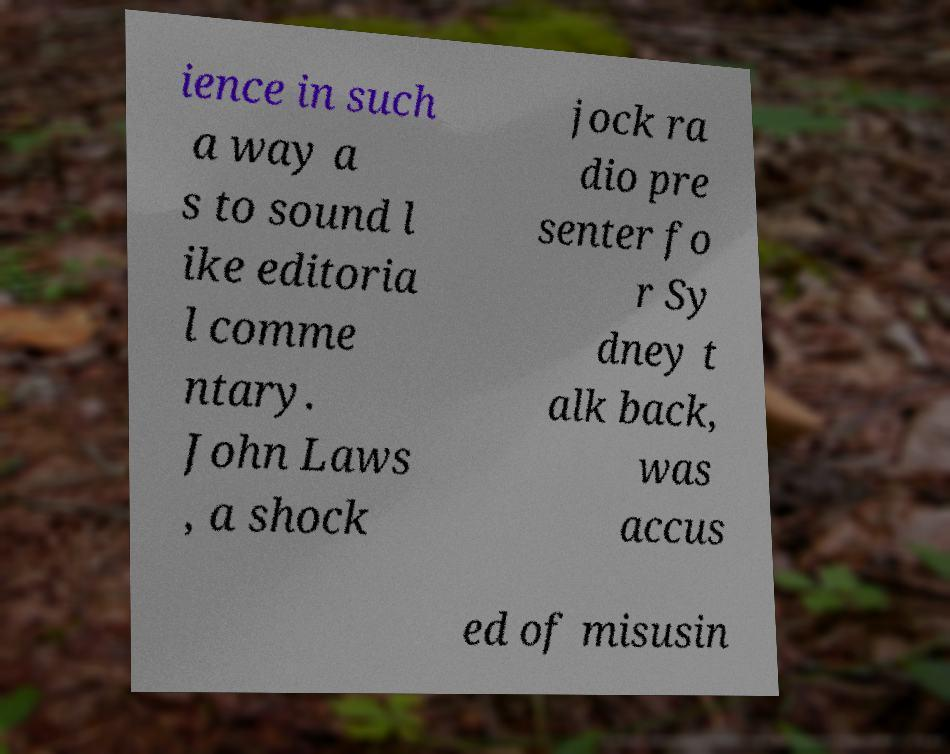Can you accurately transcribe the text from the provided image for me? ience in such a way a s to sound l ike editoria l comme ntary. John Laws , a shock jock ra dio pre senter fo r Sy dney t alk back, was accus ed of misusin 